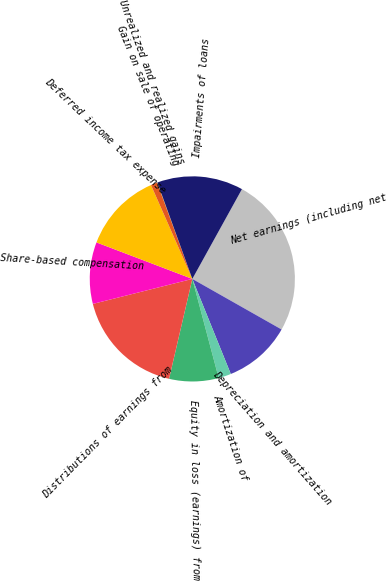Convert chart to OTSL. <chart><loc_0><loc_0><loc_500><loc_500><pie_chart><fcel>Net earnings (including net<fcel>Depreciation and amortization<fcel>Amortization of<fcel>Equity in loss (earnings) from<fcel>Distributions of earnings from<fcel>Share-based compensation<fcel>Deferred income tax expense<fcel>Gain on sale of operating<fcel>Unrealized and realized gains<fcel>Impairments of loans<nl><fcel>25.17%<fcel>10.68%<fcel>1.98%<fcel>7.78%<fcel>17.44%<fcel>9.71%<fcel>12.61%<fcel>1.02%<fcel>0.05%<fcel>13.57%<nl></chart> 